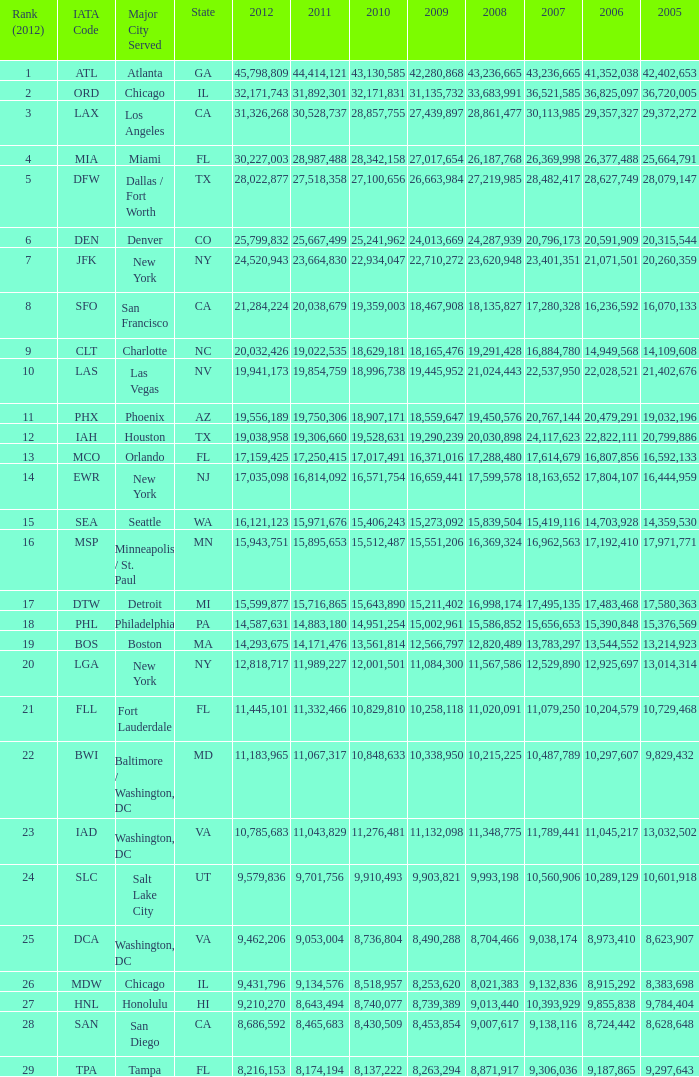What is the total sum for 2012 when the iata code is lax, with 2009 having less than 31,135,732 and 2011 having less than 8,174,194? 0.0. 